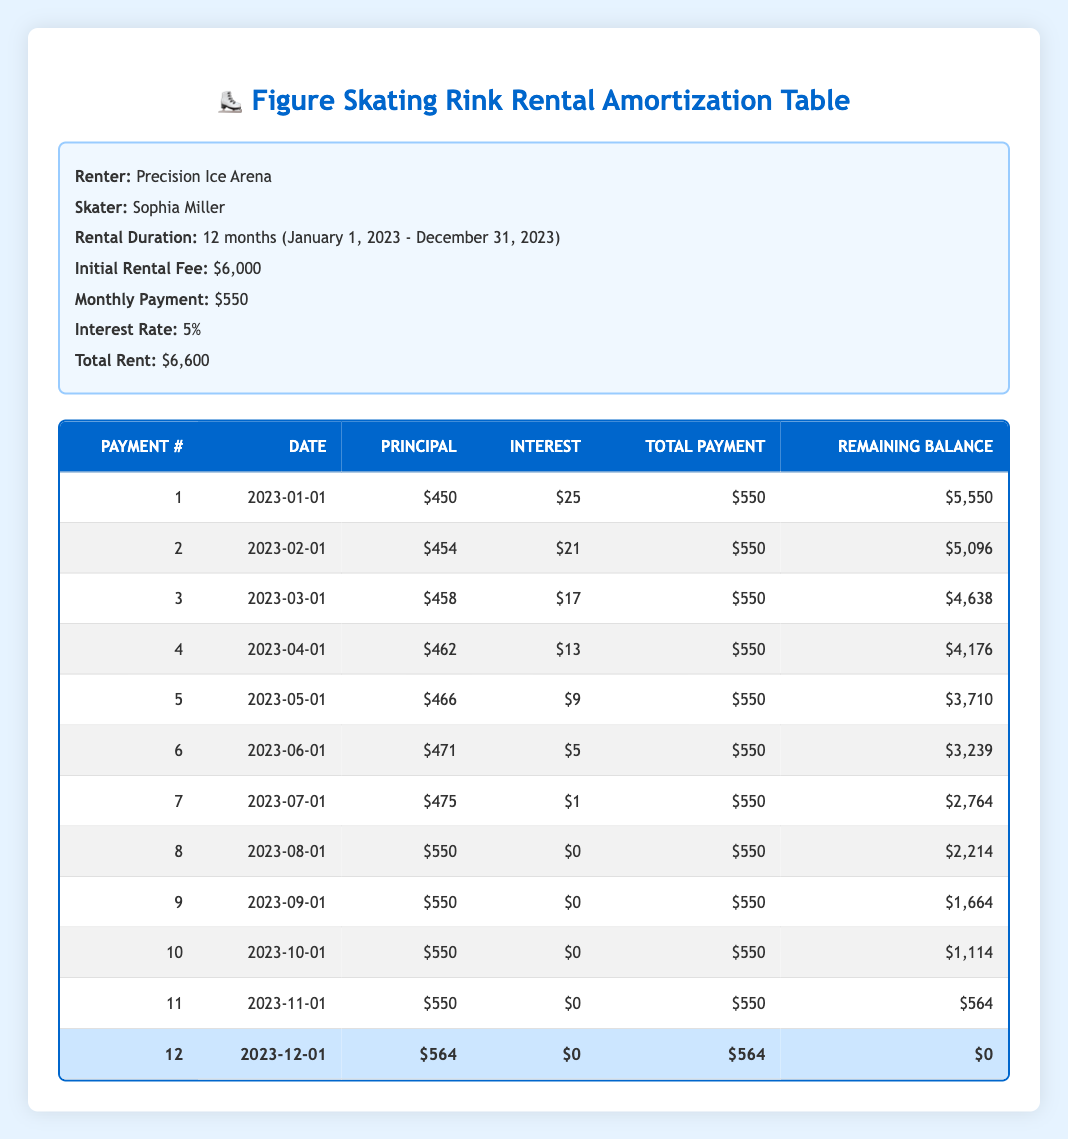What is the total amount paid over the rental duration? To find the total amount paid, sum the total payments made each month. Each month's payment is $550 for the first eleven months, with the last payment being $564. Therefore, calculating: (11 * 550) + 564 = 6050 + 564 = 6614
Answer: 6614 How much is the principal payment in the third month? In the payment schedule, the principal payment for the third month (March 1, 2023) is listed as $458.
Answer: 458 Was the interest payment ever zero during any month? By reviewing each month's interest payment, we see that it was only zero during the eighth month (August 1, 2023) and the following months, as they paid off the principal at that point.
Answer: Yes How much did the remaining balance decrease from the first month to the last month? The remaining balance at the end of the first month is $5,550, and at the end of the twelfth month, it is $0. Thus, the decrease is calculated as: $5,550 - $0 = $5,550.
Answer: 5550 What is the average monthly principal payment over the rental duration? The principal payments across the 12 months can be summed: 450 + 454 + 458 + 462 + 466 + 471 + 475 + 550 + 550 + 550 + 550 + 564 = 5068. Then, divide by the number of months (12): 5068 / 12 = approximately 422.33.
Answer: 422.33 What percentage of the total rent does the interest amount to? The total rent is $6,600. The total interest paid over the duration can be calculated by summing the interest payments, which are: 25 + 21 + 17 + 13 + 9 + 5 + 1 + 0 + 0 + 0 + 0 + 0 = 91. To find the percentage: (91/6600) * 100 = approximately 1.38%.
Answer: 1.38% Did the principal payment increase each month? By evaluating the principal payments for each month listed, we can observe that while many months the payment increased, in some instances, such as the seventh month, the increase was minimal. Thus, it did not strictly increase each month.
Answer: No How much did the monthly payment stay the same over the months? According to the payment schedule, the monthly payment was consistently $550 for the first eleven months until the twelfth month, where it was $564. Thus, it stayed the same for eleven months before changing.
Answer: 11 months 